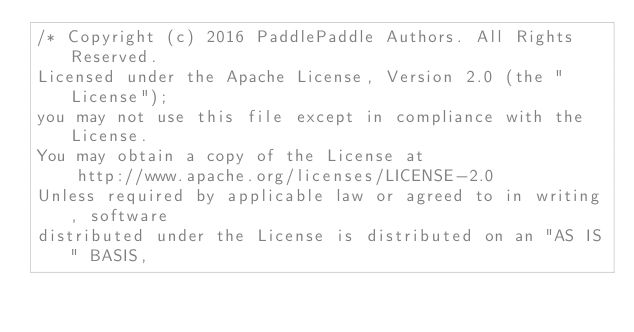<code> <loc_0><loc_0><loc_500><loc_500><_Cuda_>/* Copyright (c) 2016 PaddlePaddle Authors. All Rights Reserved.
Licensed under the Apache License, Version 2.0 (the "License");
you may not use this file except in compliance with the License.
You may obtain a copy of the License at
    http://www.apache.org/licenses/LICENSE-2.0
Unless required by applicable law or agreed to in writing, software
distributed under the License is distributed on an "AS IS" BASIS,</code> 